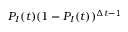<formula> <loc_0><loc_0><loc_500><loc_500>P _ { I } ( t ) ( 1 - P _ { I } ( t ) ) ^ { \Delta t - 1 }</formula> 